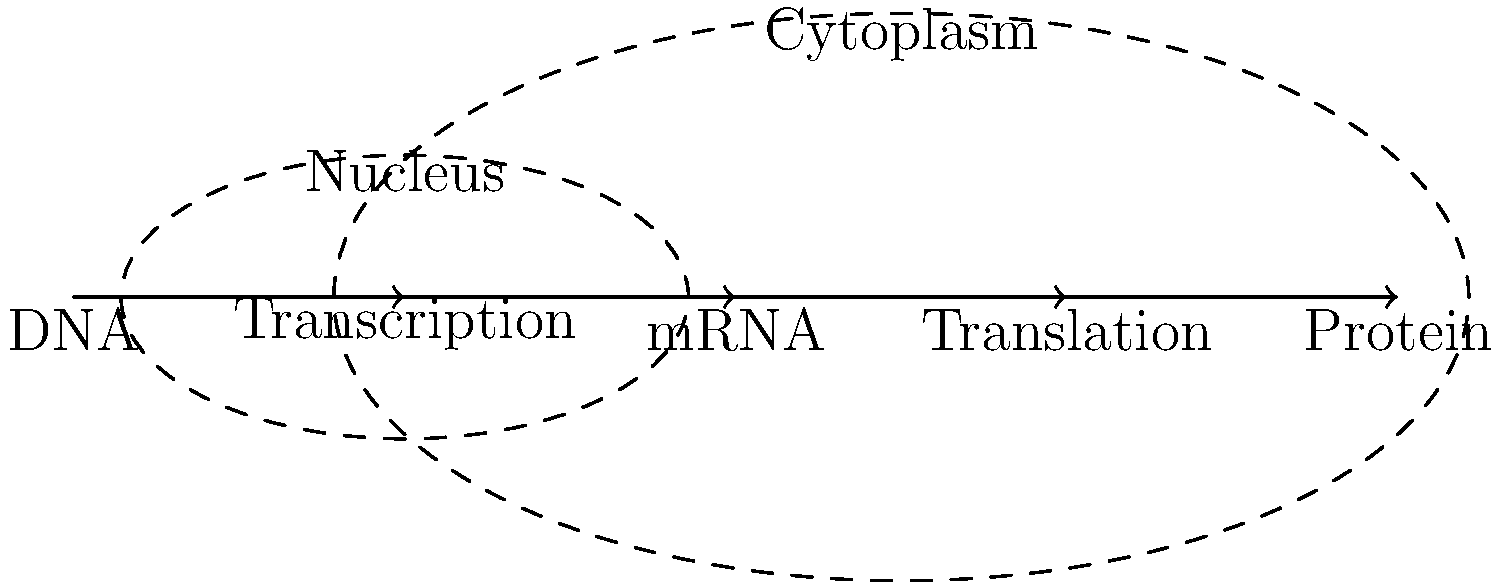En el diagrama que ilustra las etapas de la expresión génica desde el ADN hasta la proteína, ¿qué proceso ocurre específicamente dentro del núcleo celular? Para responder a esta pregunta, debemos analizar el diagrama paso a paso:

1. El diagrama muestra las etapas principales de la expresión génica, desde el ADN hasta la proteína.

2. Las etapas están representadas en orden: ADN → Transcripción → ARNm → Traducción → Proteína.

3. Observamos que hay dos regiones celulares delimitadas por líneas punteadas:
   a) Una región más pequeña etiquetada como "Nucleus" (Núcleo).
   b) Una región más grande etiquetada como "Cytoplasm" (Citoplasma).

4. Dentro de la región del núcleo, vemos las etapas de ADN y Transcripción.

5. La transcripción es el proceso por el cual la información del ADN se copia en forma de ARN mensajero (ARNm).

6. Las etapas posteriores (ARNm, Traducción y Proteína) se muestran fuera del núcleo, en el citoplasma.

Por lo tanto, el proceso que ocurre específicamente dentro del núcleo celular es la transcripción.

Esta información es crucial para un emprendedor de biotecnología desarrollando nuevas terapias, ya que comprender los procesos celulares fundamentales es esencial para diseñar intervenciones terapéuticas efectivas a nivel molecular.
Answer: Transcripción 